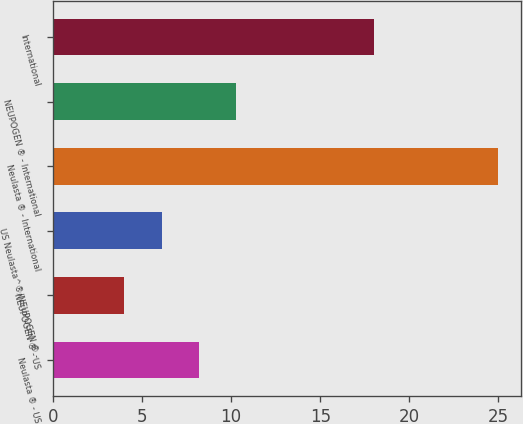Convert chart to OTSL. <chart><loc_0><loc_0><loc_500><loc_500><bar_chart><fcel>Neulasta ® - US<fcel>NEUPOGEN ® - US<fcel>US Neulasta^®/NEUPOGEN ® -<fcel>Neulasta ® - International<fcel>NEUPOGEN ® - International<fcel>International<nl><fcel>8.2<fcel>4<fcel>6.1<fcel>25<fcel>10.3<fcel>18<nl></chart> 